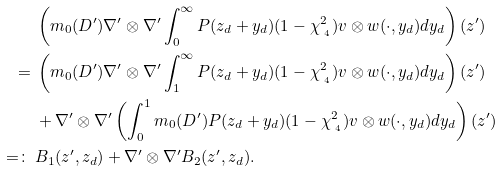Convert formula to latex. <formula><loc_0><loc_0><loc_500><loc_500>& \left ( m _ { 0 } ( D ^ { \prime } ) \nabla ^ { \prime } \otimes \nabla ^ { \prime } \int _ { 0 } ^ { \infty } P ( z _ { d } + y _ { d } ) ( 1 - \chi _ { \, _ { \, 4 } } ^ { 2 } ) v \otimes w ( \cdot , y _ { d } ) d y _ { d } \right ) ( z ^ { \prime } ) \\ = \ & \left ( m _ { 0 } ( D ^ { \prime } ) \nabla ^ { \prime } \otimes \nabla ^ { \prime } \int _ { 1 } ^ { \infty } P ( z _ { d } + y _ { d } ) ( 1 - \chi _ { \, _ { \, 4 } } ^ { 2 } ) v \otimes w ( \cdot , y _ { d } ) d y _ { d } \right ) ( z ^ { \prime } ) \\ & + \nabla ^ { \prime } \otimes \nabla ^ { \prime } \left ( \int _ { 0 } ^ { 1 } m _ { 0 } ( D ^ { \prime } ) P ( z _ { d } + y _ { d } ) ( 1 - \chi _ { \, _ { \, 4 } } ^ { 2 } ) v \otimes w ( \cdot , y _ { d } ) d y _ { d } \right ) ( z ^ { \prime } ) \\ = \colon \ & B _ { 1 } ( z ^ { \prime } , z _ { d } ) + \nabla ^ { \prime } \otimes \nabla ^ { \prime } B _ { 2 } ( z ^ { \prime } , z _ { d } ) .</formula> 